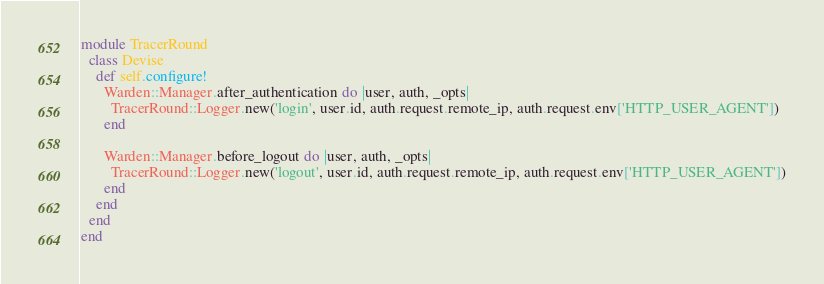<code> <loc_0><loc_0><loc_500><loc_500><_Ruby_>module TracerRound
  class Devise
    def self.configure!
      Warden::Manager.after_authentication do |user, auth, _opts|
        TracerRound::Logger.new('login', user.id, auth.request.remote_ip, auth.request.env['HTTP_USER_AGENT'])
      end

      Warden::Manager.before_logout do |user, auth, _opts|
        TracerRound::Logger.new('logout', user.id, auth.request.remote_ip, auth.request.env['HTTP_USER_AGENT'])
      end
    end
  end
end
</code> 